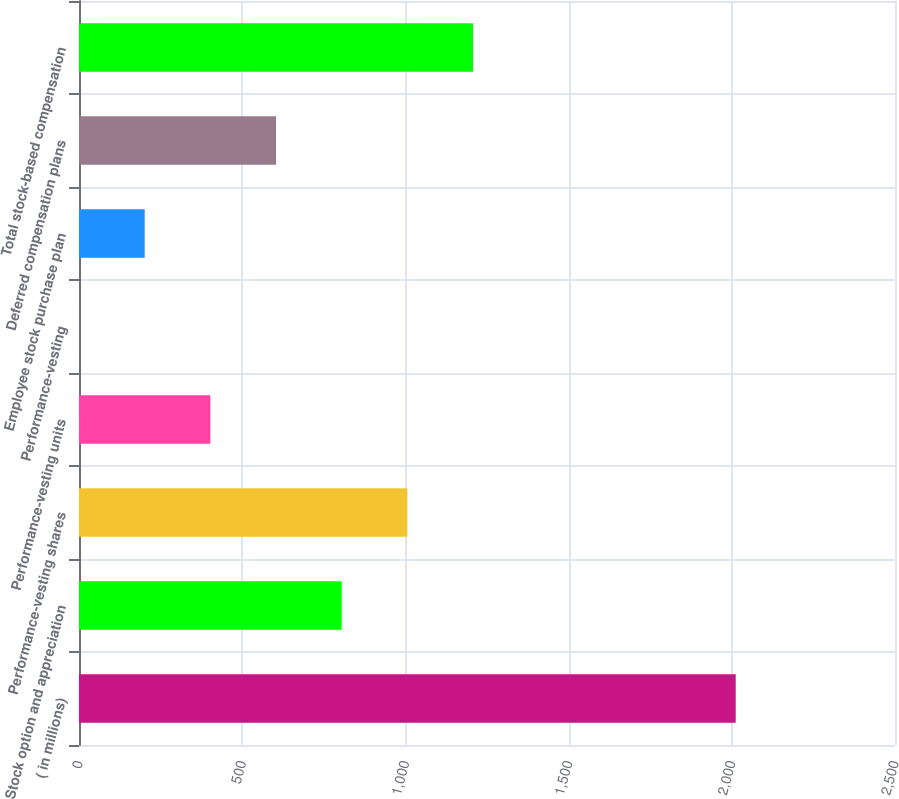<chart> <loc_0><loc_0><loc_500><loc_500><bar_chart><fcel>( in millions)<fcel>Stock option and appreciation<fcel>Performance-vesting shares<fcel>Performance-vesting units<fcel>Performance-vesting<fcel>Employee stock purchase plan<fcel>Deferred compensation plans<fcel>Total stock-based compensation<nl><fcel>2012<fcel>804.86<fcel>1006.05<fcel>402.48<fcel>0.1<fcel>201.29<fcel>603.67<fcel>1207.24<nl></chart> 